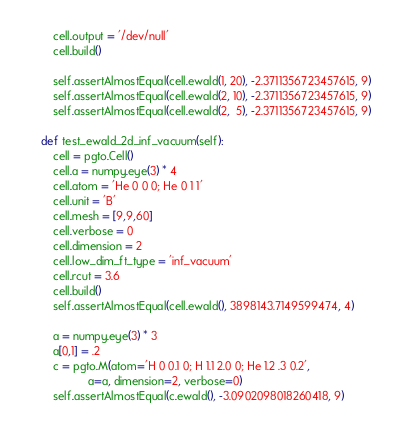<code> <loc_0><loc_0><loc_500><loc_500><_Python_>        cell.output = '/dev/null'
        cell.build()

        self.assertAlmostEqual(cell.ewald(1, 20), -2.3711356723457615, 9)
        self.assertAlmostEqual(cell.ewald(2, 10), -2.3711356723457615, 9)
        self.assertAlmostEqual(cell.ewald(2,  5), -2.3711356723457615, 9)

    def test_ewald_2d_inf_vacuum(self):
        cell = pgto.Cell()
        cell.a = numpy.eye(3) * 4
        cell.atom = 'He 0 0 0; He 0 1 1'
        cell.unit = 'B'
        cell.mesh = [9,9,60]
        cell.verbose = 0
        cell.dimension = 2
        cell.low_dim_ft_type = 'inf_vacuum'
        cell.rcut = 3.6
        cell.build()
        self.assertAlmostEqual(cell.ewald(), 3898143.7149599474, 4)

        a = numpy.eye(3) * 3
        a[0,1] = .2
        c = pgto.M(atom='H 0 0.1 0; H 1.1 2.0 0; He 1.2 .3 0.2',
                   a=a, dimension=2, verbose=0)
        self.assertAlmostEqual(c.ewald(), -3.0902098018260418, 9)
</code> 